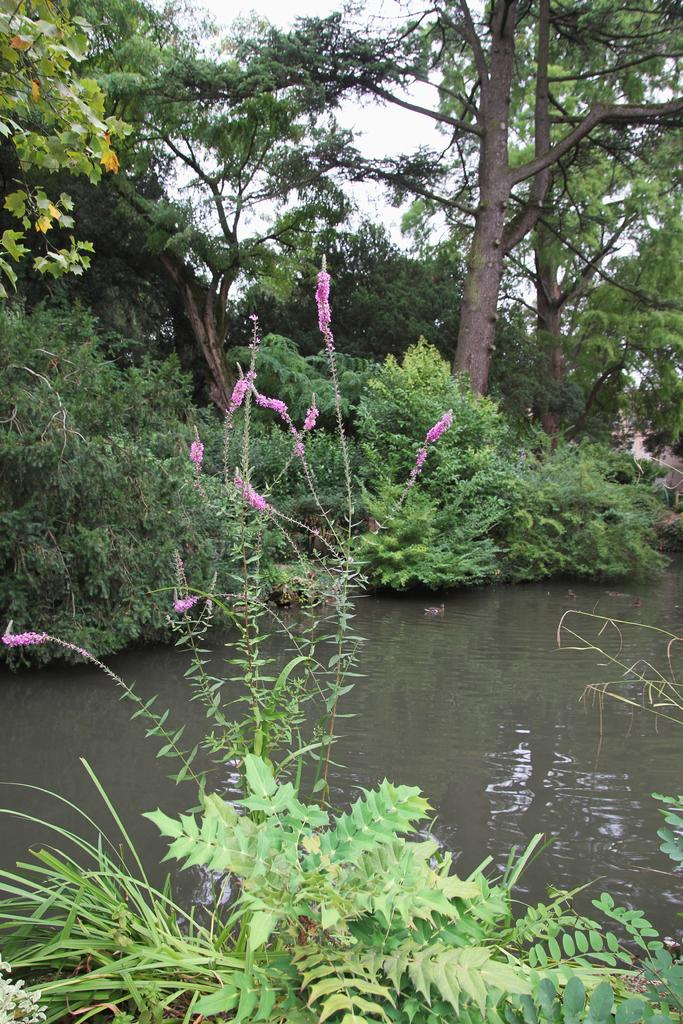What type of living organisms can be seen in the image? Plants and trees are visible in the image. What is the primary element in which the plants are situated? There is water visible in the image, and the plants are situated in it. What can be seen in the background of the image? The sky is visible in the background of the image. What type of dinner is being served in the image? There is no dinner present in the image; it features plants, water, trees, and the sky. 